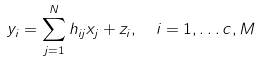Convert formula to latex. <formula><loc_0><loc_0><loc_500><loc_500>y _ { i } & = \sum _ { j = 1 } ^ { N } h _ { i j } x _ { j } + z _ { i } , \quad i = 1 , \dots c , M</formula> 